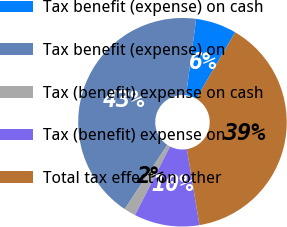<chart> <loc_0><loc_0><loc_500><loc_500><pie_chart><fcel>Tax benefit (expense) on cash<fcel>Tax benefit (expense) on<fcel>Tax (benefit) expense on cash<fcel>Tax (benefit) expense on<fcel>Total tax effect on other<nl><fcel>6.33%<fcel>42.75%<fcel>1.83%<fcel>10.13%<fcel>38.96%<nl></chart> 